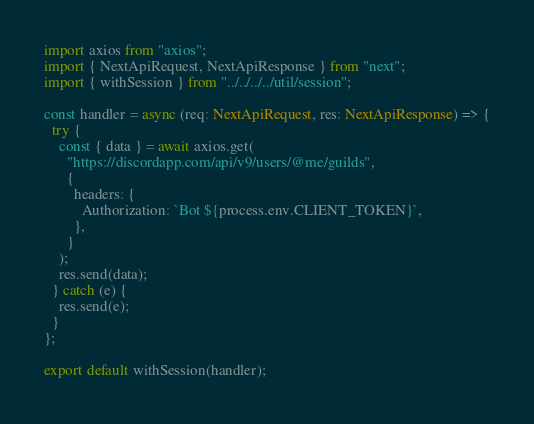<code> <loc_0><loc_0><loc_500><loc_500><_TypeScript_>import axios from "axios";
import { NextApiRequest, NextApiResponse } from "next";
import { withSession } from "../../../../util/session";

const handler = async (req: NextApiRequest, res: NextApiResponse) => {
  try {
    const { data } = await axios.get(
      "https://discordapp.com/api/v9/users/@me/guilds",
      {
        headers: {
          Authorization: `Bot ${process.env.CLIENT_TOKEN}`,
        },
      }
    );
    res.send(data);
  } catch (e) {
    res.send(e);
  }
};

export default withSession(handler);
</code> 